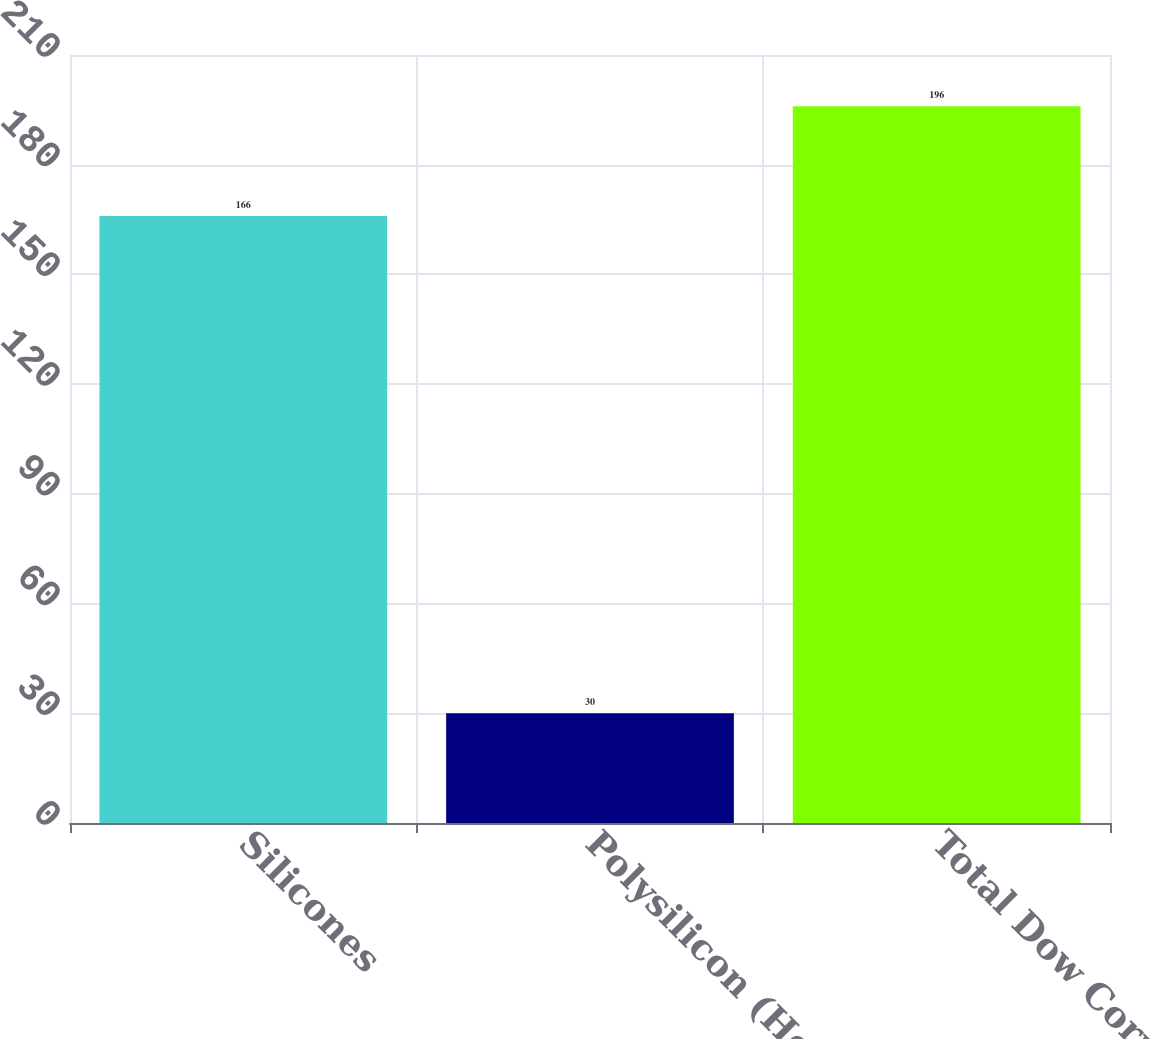Convert chart. <chart><loc_0><loc_0><loc_500><loc_500><bar_chart><fcel>Silicones<fcel>Polysilicon (Hemlock<fcel>Total Dow Corning<nl><fcel>166<fcel>30<fcel>196<nl></chart> 